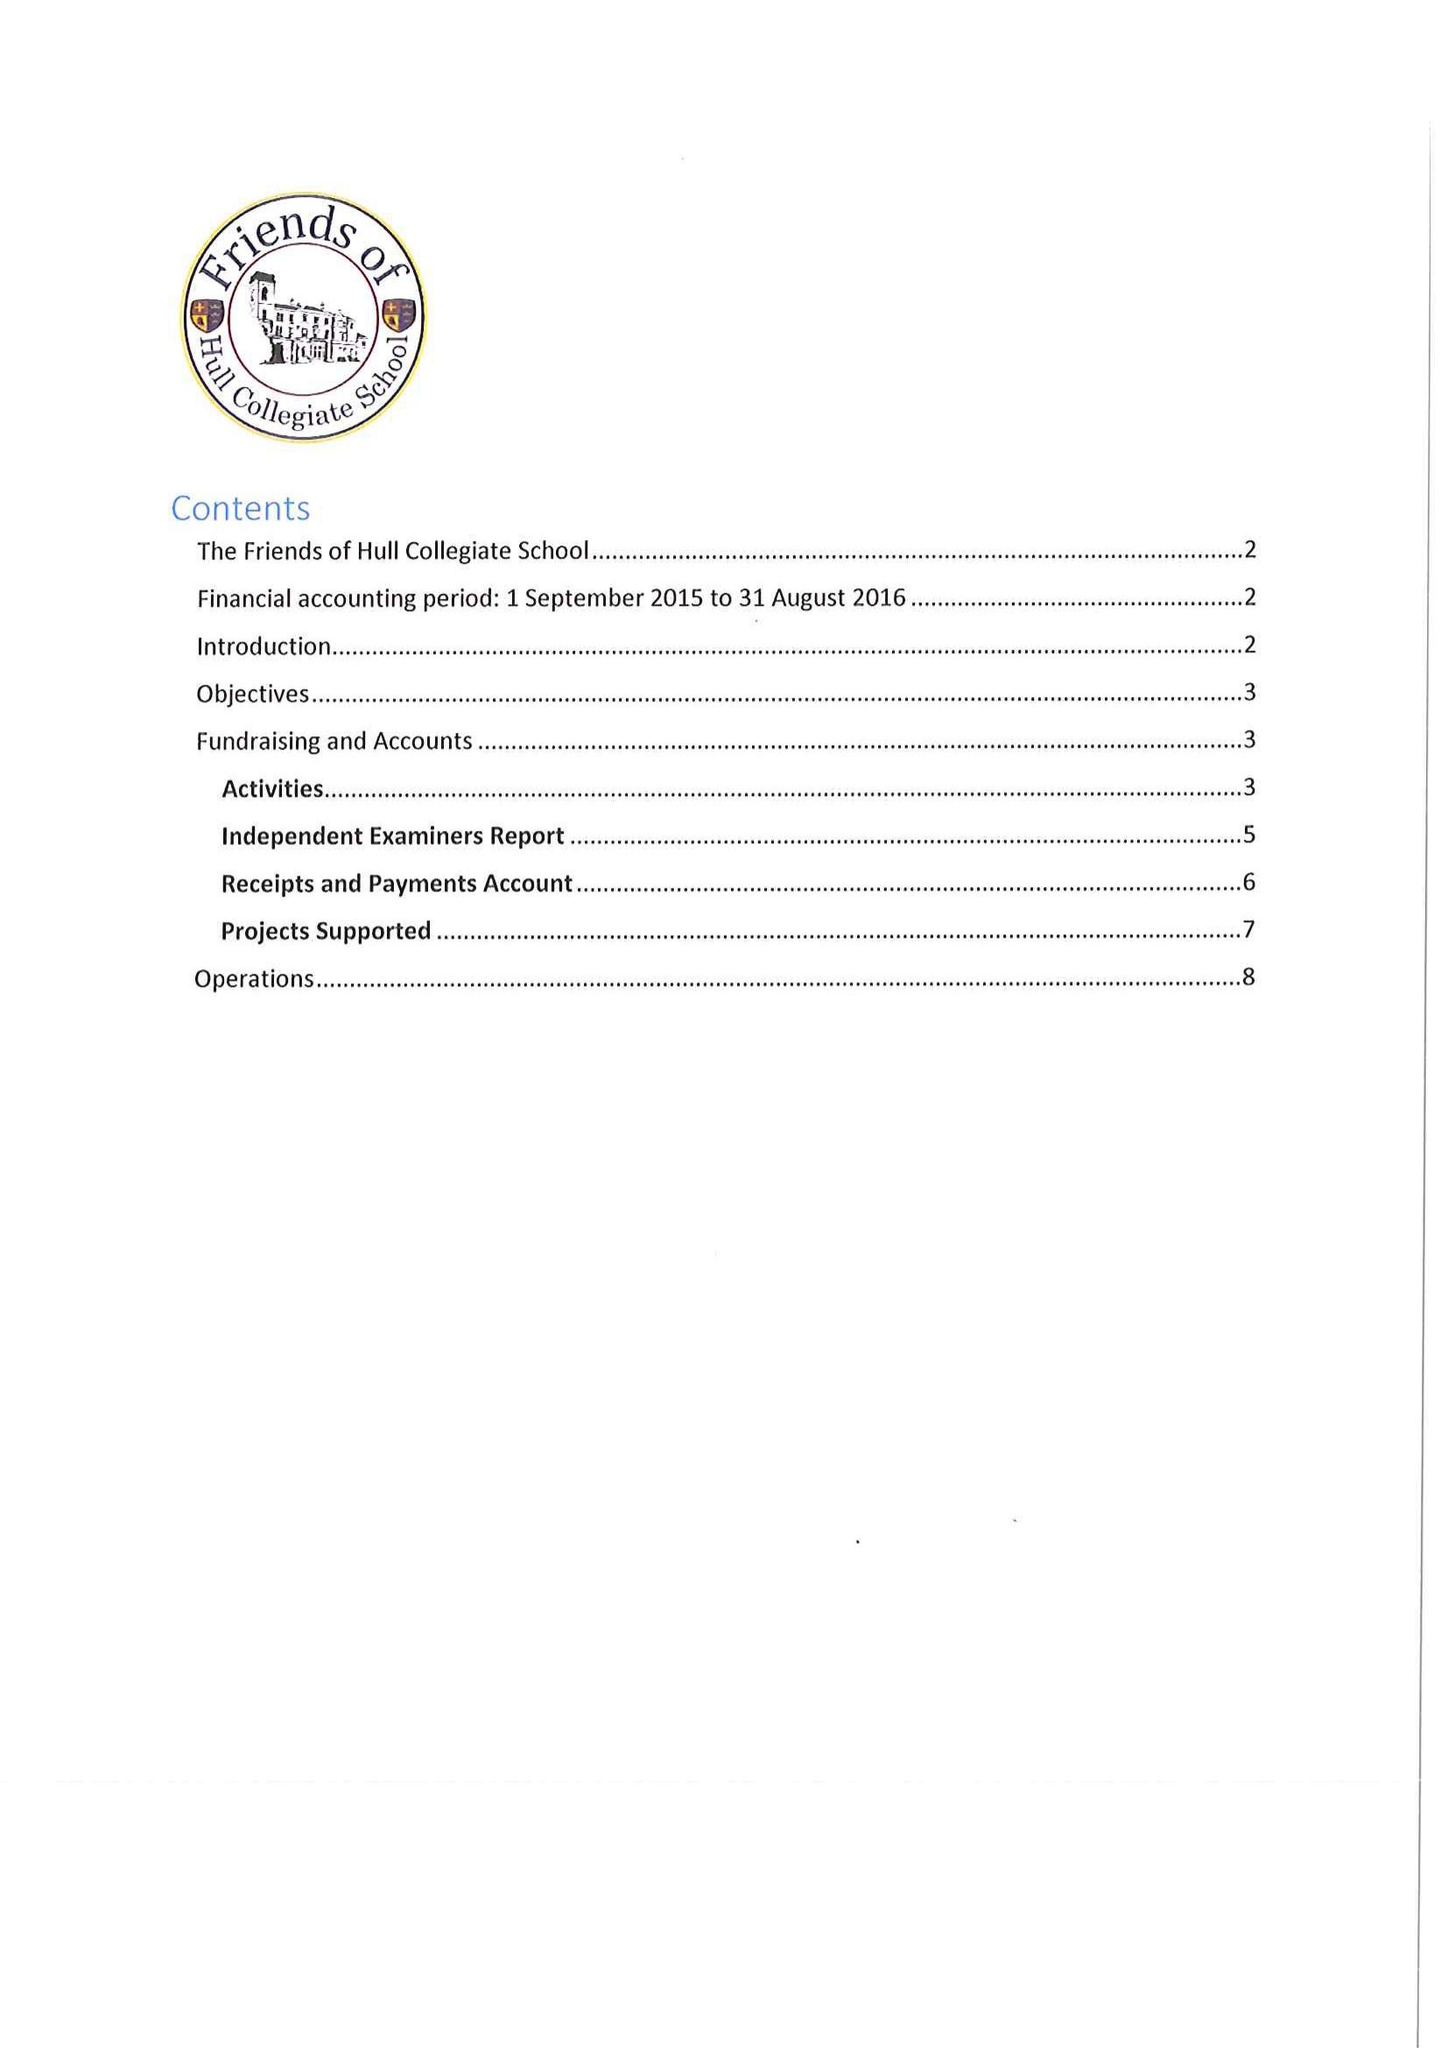What is the value for the address__street_line?
Answer the question using a single word or phrase. None 